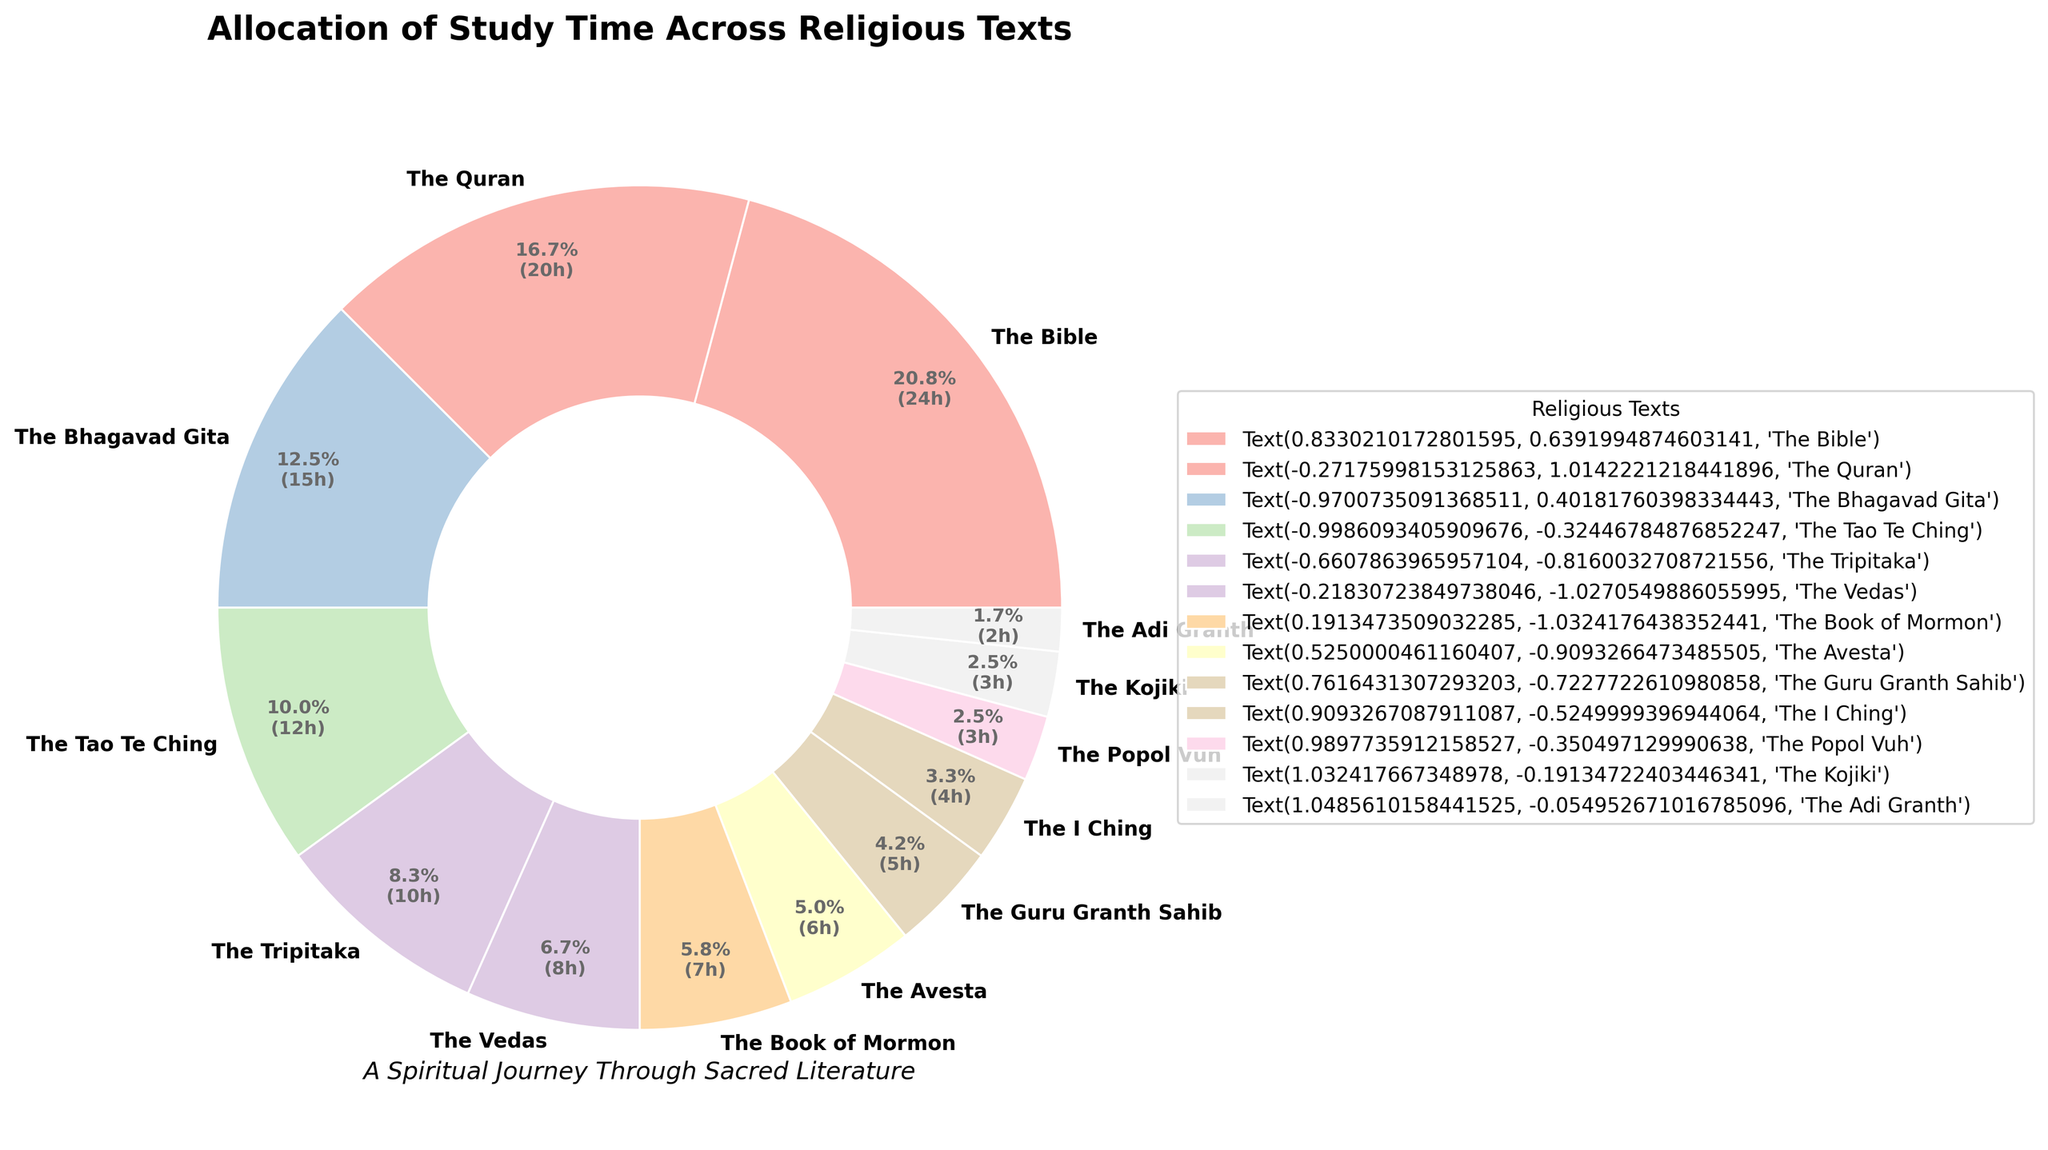Which religious text received the most study time? The text with the largest percentage in the pie chart indicates the most study time allocation. In this case, the Bible has the largest segment.
Answer: The Bible Which two texts together account for more than 50% of the study time? Identify the two largest segments in the pie chart and sum their percentages. The Bible is about 25% and the Quran is about 20%. Together, they sum to approximately 45%, not exceeding 50%. The next largest segment, the Bhagavad Gita, adds 15%. The sum of the Bible and the Quran slightly misses 50%, but including the Bhagavad Gita would reach beyond 50%.
Answer: The Bible and the Quran and the Bhagavad Gita Which religious text has the smallest allocation of study time? The smallest segment in the pie chart represents the text with the smallest allocation. This is the Adi Granth.
Answer: The Adi Granth How much more study time is allocated to the Bible compared to the Avesta? Calculate the difference in hours of study time between the Bible and the Avesta. The Bible has 25 hours, and the Avesta has 6 hours. The difference is 25 - 6 = 19 hours.
Answer: 19 hours What percentage of the total study time is allocated to the Vedas and the Tripitaka combined? Look for the segments representing the Vedas and the Tripitaka in the pie chart and sum their percentages. The Vedas are about 8% and the Tripitaka about 10%. Combined, this makes 8% + 10% = 18%.
Answer: 18% How does the study time for the Bhagavad Gita compare to the Guru Granth Sahib? Compare the sizes of the segments corresponding to the Bhagavad Gita and the Guru Granth Sahib. The Bhagavad Gita has a significantly larger segment, indicating more study time.
Answer: The Bhagavad Gita has more study time What is the difference in study time between the Book of Mormon and the I Ching? Calculate the difference in hours between the Book of Mormon (7 hours) and the I Ching (4 hours). The difference is 7 - 4 = 3 hours.
Answer: 3 hours Which three texts combined make up approximately 30% of the study time? Identify three texts whose combined percentages approach 30%. The Tao Te Ching (about 12%), the Tripitaka (about 10%), and the Vedas (about 8%) together sum up to 12% + 10% + 8% = 30%.
Answer: The Tao Te Ching, the Tripitaka, and the Vedas Which text has an allocation of study time that is most visually similar to that of the I Ching? Visually compare the sizes of the segments in the pie chart. The I Ching and the Kojiki have almost similar segment sizes, indicating a similar allocation of study time.
Answer: The Kojiki 